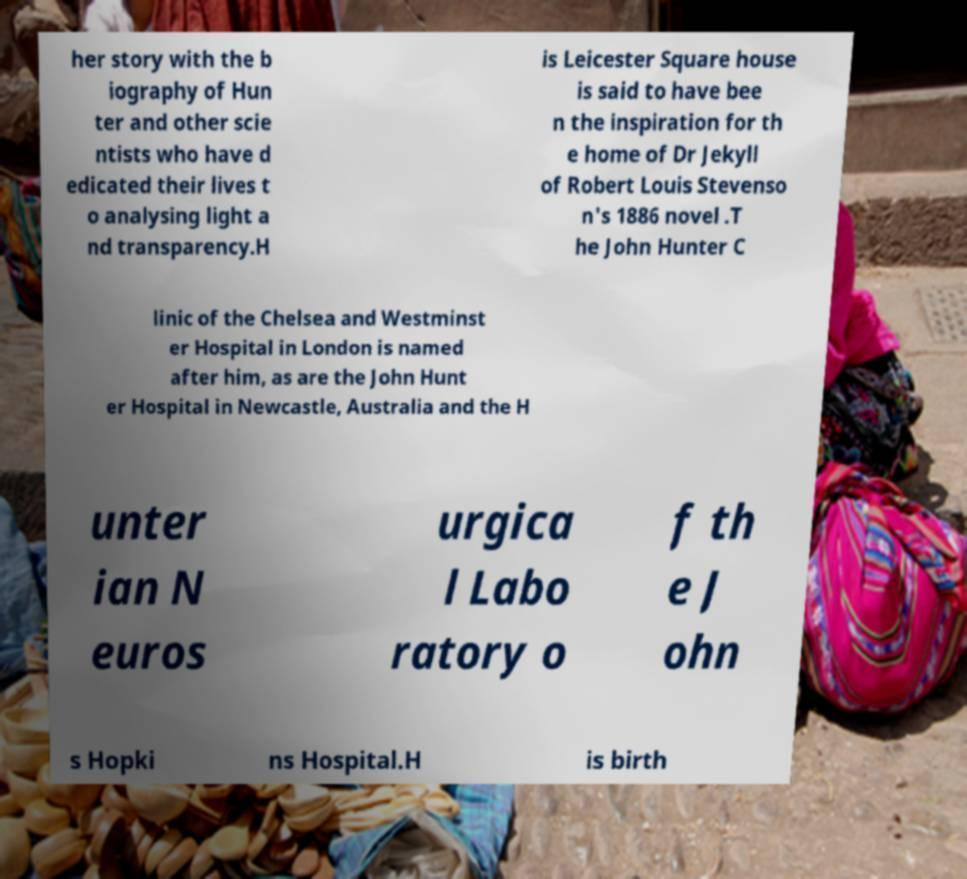Please identify and transcribe the text found in this image. her story with the b iography of Hun ter and other scie ntists who have d edicated their lives t o analysing light a nd transparency.H is Leicester Square house is said to have bee n the inspiration for th e home of Dr Jekyll of Robert Louis Stevenso n's 1886 novel .T he John Hunter C linic of the Chelsea and Westminst er Hospital in London is named after him, as are the John Hunt er Hospital in Newcastle, Australia and the H unter ian N euros urgica l Labo ratory o f th e J ohn s Hopki ns Hospital.H is birth 